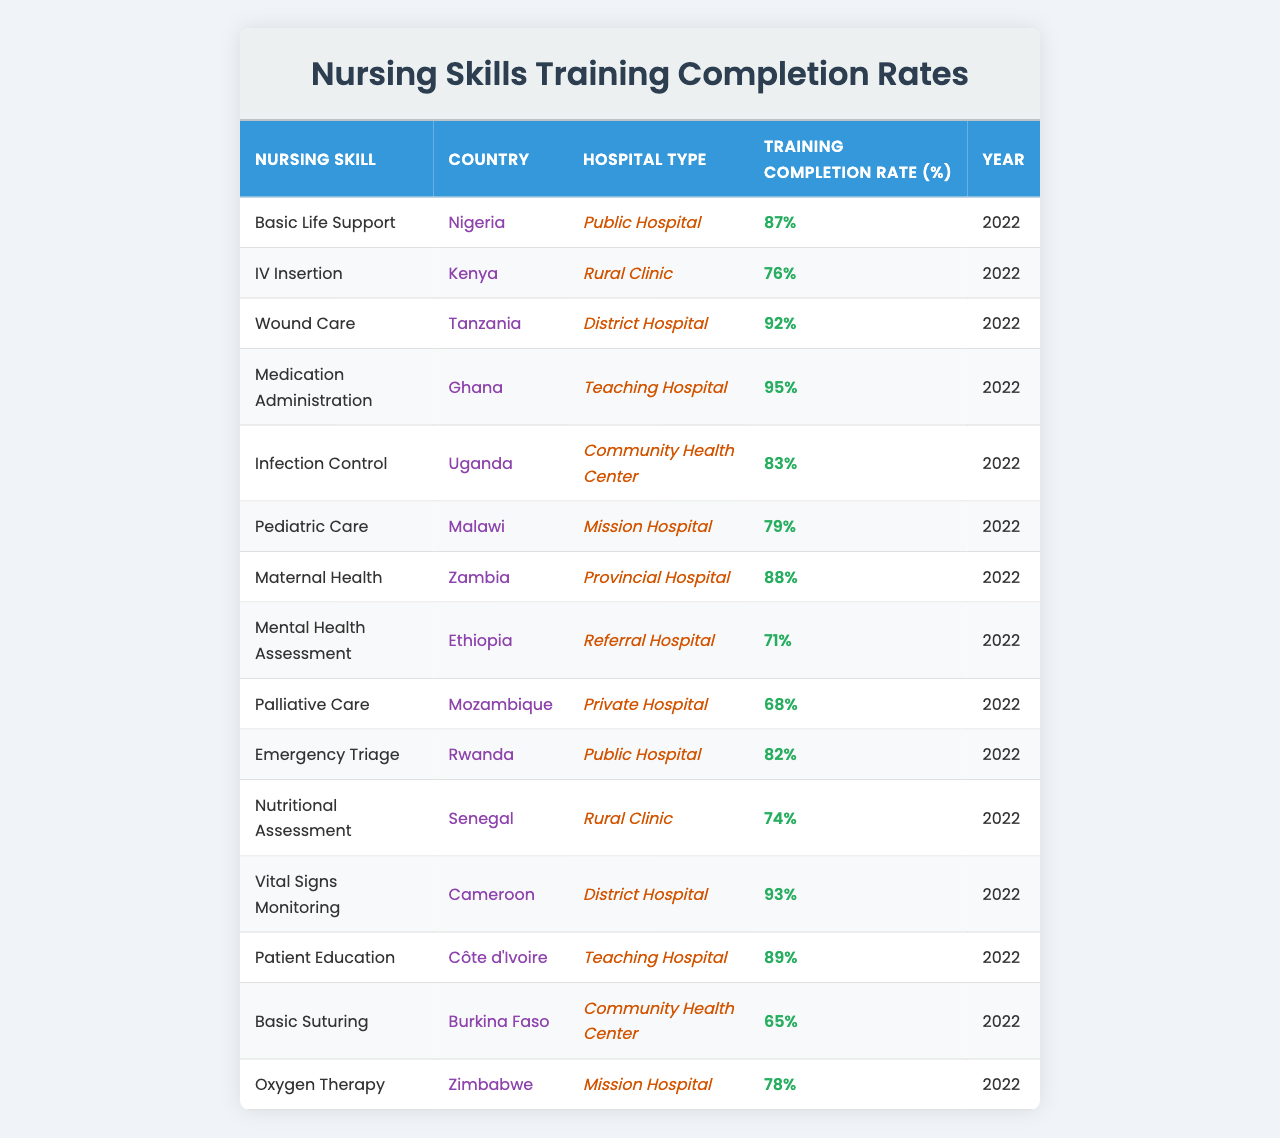What is the training completion rate for Medication Administration in Ghana? The table shows that the training completion rate for Medication Administration is 95% in Ghana.
Answer: 95% Which country has the lowest training completion rate for a nursing skill? By reviewing the data, Palliative Care in Mozambique has the lowest training completion rate at 68%.
Answer: Mozambique How many countries have a training completion rate above 80%? By examining each country's completion rates listed in the table, they are Nigeria (87%), Tanzania (92%), Ghana (95%), Zambia (88%), Cameroon (93%), Côte d'Ivoire (89%), and Uganda (83%), totaling 7 countries.
Answer: 7 What is the average training completion rate across all nursing skills listed? To find the average, add all completion rates (87 + 76 + 92 + 95 + 83 + 79 + 88 + 71 + 68 + 82 + 74 + 93 + 89 + 65 + 78) which equals 1295, then divide by the number of skills (15), resulting in an average of approximately 86.33%.
Answer: 86.33% Is the training completion rate for Basic Life Support higher than that for Pediatric Care? The table indicates that Basic Life Support's completion rate is 87% and Pediatric Care's completion rate is 79%. Since 87% is higher than 79%, the statement is true.
Answer: Yes Which hospital type has the highest completion rate, and what is that rate? By analyzing the data, the Teaching Hospital in Ghana has the highest completion rate at 95%.
Answer: Teaching Hospital, 95% How does the training completion rate for Infection Control in Uganda compare to that for Nutritional Assessment in Senegal? The completion rate for Infection Control in Uganda is 83%, while Nutritional Assessment in Senegal is 74%. Since 83% is greater than 74%, Infection Control has a higher rate.
Answer: Higher for Infection Control What is the difference in training completion rates between Mental Health Assessment in Ethiopia and Basic Suturing in Burkina Faso? Mental Health Assessment has a completion rate of 71% and Basic Suturing has a completion rate of 65%. The difference is 71% - 65% = 6%.
Answer: 6% Which country has a higher training completion rate: Malawi or Uganda? In the table, Malawi's Pediatric Care completion rate is listed at 79%, and Uganda's Infection Control is at 83%. Since 83% is greater than 79%, Uganda has the higher rate.
Answer: Uganda If we consider the training completion rates for all rural clinics listed, what is their average? The rates for rural clinics are 76% (Kenya) and 74% (Senegal). The sum is 76 + 74 = 150, then average this by dividing by 2, which equals 75%.
Answer: 75% 